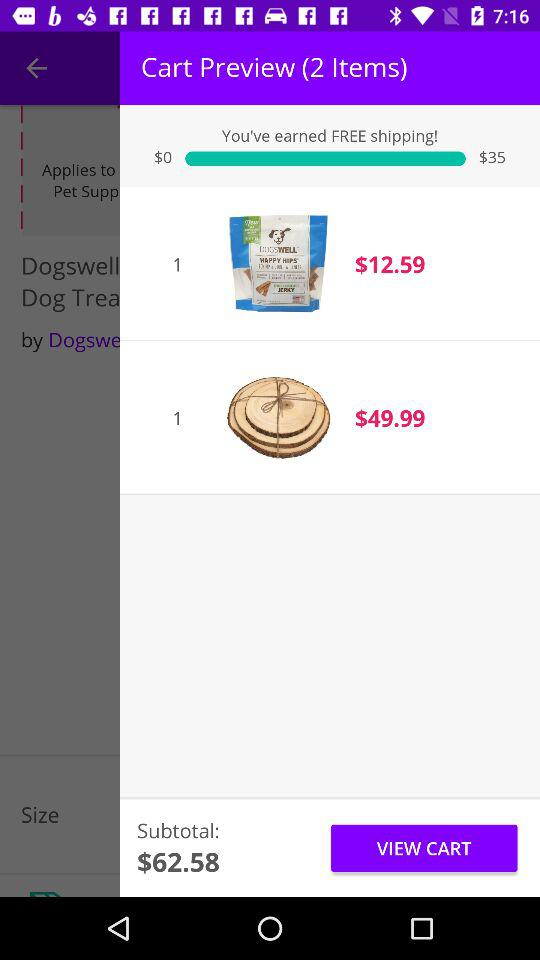How much is the total amount of the items?
Answer the question using a single word or phrase. $62.58 